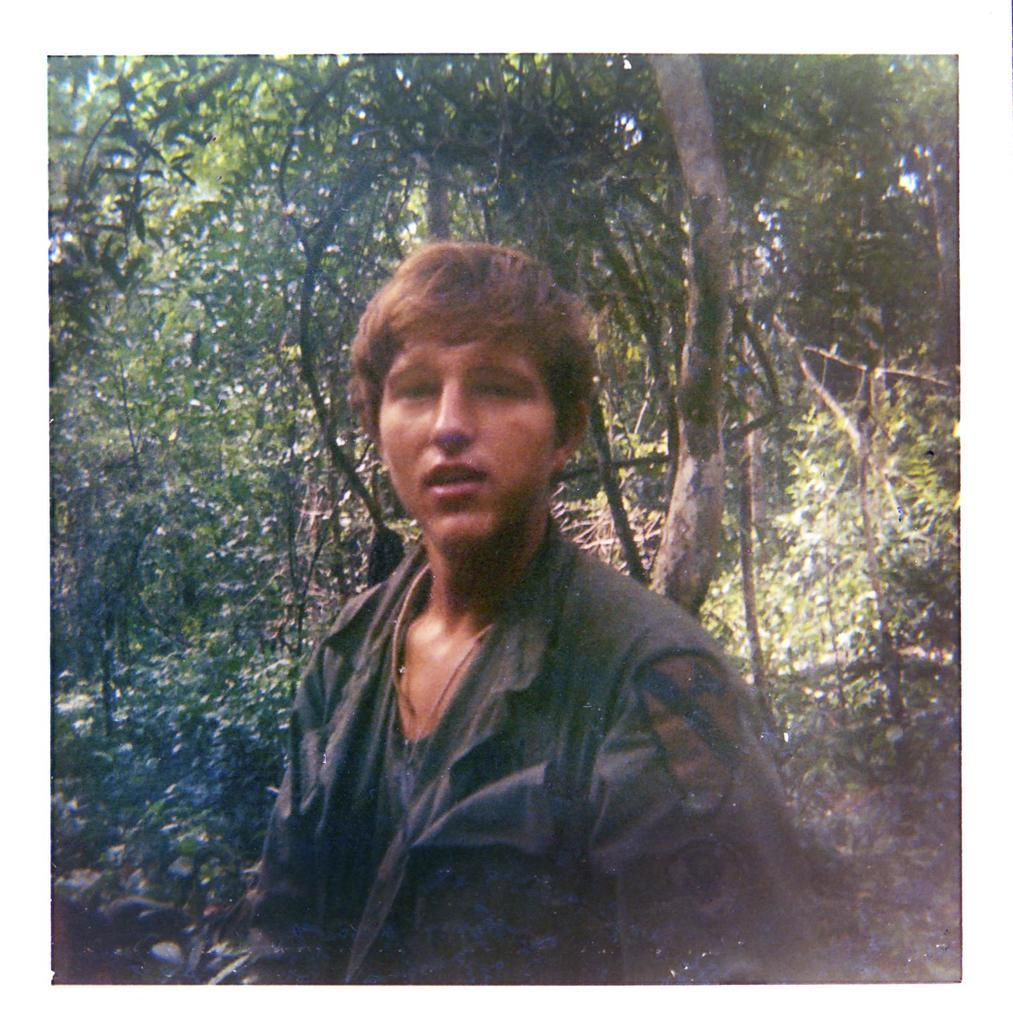Who or what is the main subject in the center of the image? There is a person in the center of the image. What can be seen in the background of the image? There are trees in the background of the image. What type of pancake is being served on the table in the image? There is no table or pancake present in the image; it features a person and trees in the background. 